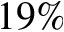<formula> <loc_0><loc_0><loc_500><loc_500>1 9 \%</formula> 